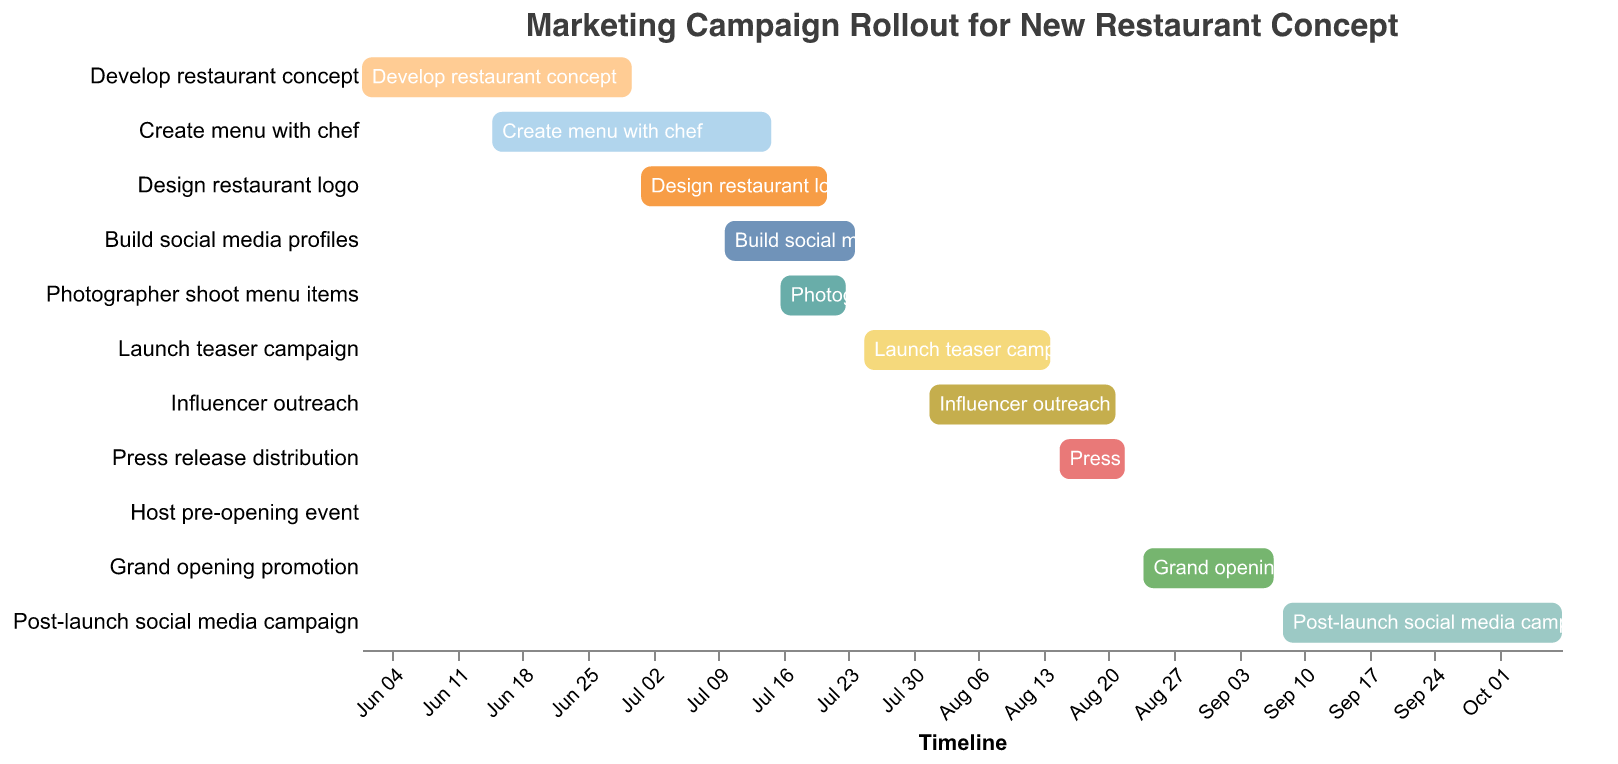What is the title of the Gantt chart? The title is usually found at the top of the Gantt chart, and it summarizes what the chart represents.
Answer: Marketing Campaign Rollout for New Restaurant Concept When does the task "Create menu with chef" start and end? The start and end dates for each task are noted along the timeline axis for easy referencing.
Answer: Starts on June 15, 2023, and ends on July 15, 2023 How long does the "Launch teaser campaign" last? Calculate the duration by finding the difference between the end date and the start date. The start date is July 25, 2023, and the end date is August 14, 2023.
Answer: 20 days Which task on the Gantt chart has the shortest duration? The shortest task can be found by comparing the length of all the bars representing tasks. The "Host pre-opening event" is the shortest since it's a single-day task.
Answer: Host pre-opening event What is the date range for the last task in this Gantt chart? By checking the order of tasks and their respective date ranges, we find the last task is "Post-launch social media campaign" starting on September 8, 2023, and ending on October 8, 2023.
Answer: September 8, 2023, to October 8, 2023 How does the duration of "Influencer outreach" compare to "Build social media profiles"? Determine the timeline duration by comparing their start and end dates. "Influencer outreach" lasts from August 1, 2023, to August 21, 2023 (21 days), and "Build social media profiles" lasts from July 10, 2023, to July 24, 2023 (15 days).
Answer: Influencer outreach is longer by 6 days Which two tasks overlap for the maximum time period? By examining the timeline bars for overlap, the "Photographer shoot menu items" and "Build social media profiles" overlap from July 16, 2023, to July 23, 2023.
Answer: Photographer shoot menu items and Build social media profiles What tasks are active during the month of July? Tasks that fall within the month of July can be checked on the timeline. They include "Create menu with chef" (till July 15), "Design restaurant logo" (till July 21), "Build social media profiles" (July 10-24), and "Photographer shoot menu items" (July 16-23).
Answer: Create menu with chef, Design restaurant logo, Build social media profiles, Photographer shoot menu items Which task follows immediately after the "Host pre-opening event"? By observing the sequence of tasks on the Gantt chart, the task after "Host pre-opening event" (August 23, 2023) is "Grand opening promotion," starting on August 24, 2023.
Answer: Grand opening promotion When is the "Design restaurant logo" task scheduled? The Gantt chart shows that "Design restaurant logo" spans from July 1, 2023, to July 21, 2023.
Answer: July 1, 2023, to July 21, 2023 